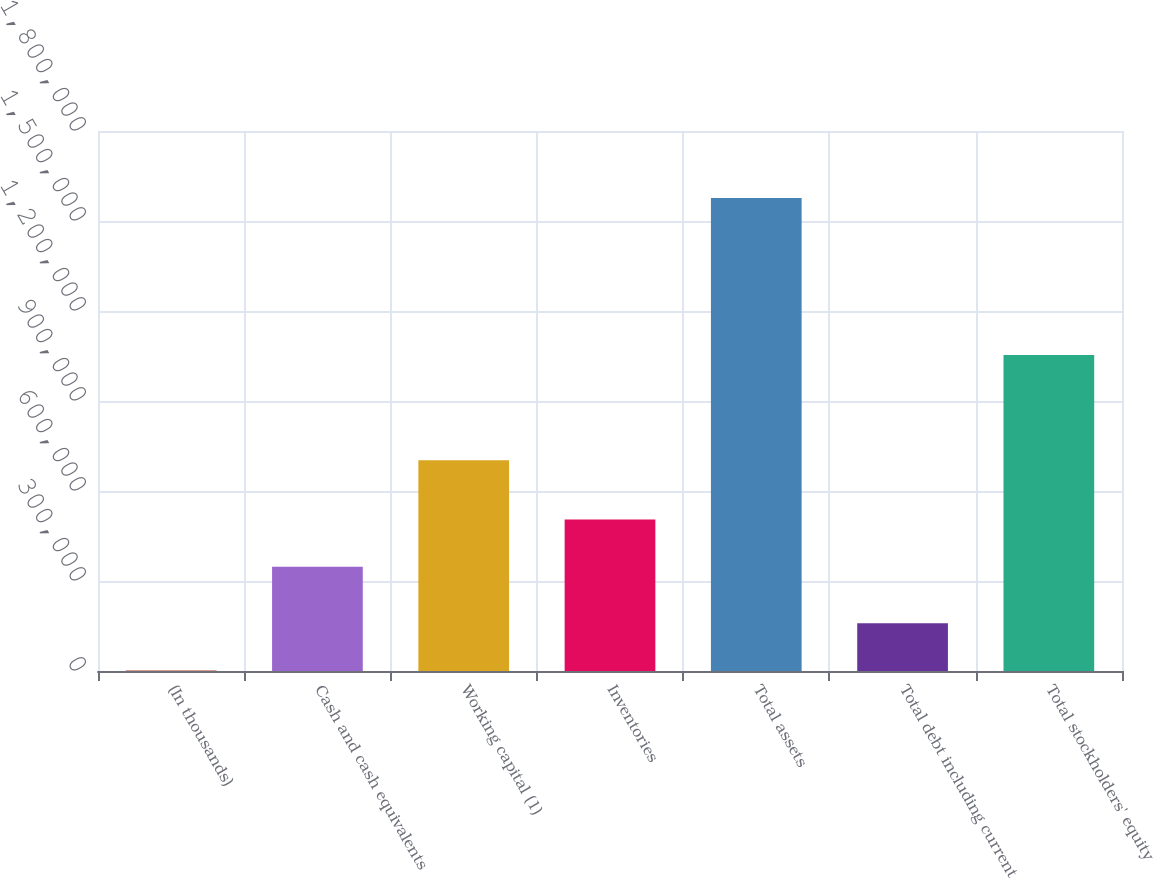<chart> <loc_0><loc_0><loc_500><loc_500><bar_chart><fcel>(In thousands)<fcel>Cash and cash equivalents<fcel>Working capital (1)<fcel>Inventories<fcel>Total assets<fcel>Total debt including current<fcel>Total stockholders' equity<nl><fcel>2013<fcel>347489<fcel>702181<fcel>504925<fcel>1.57637e+06<fcel>159449<fcel>1.05335e+06<nl></chart> 